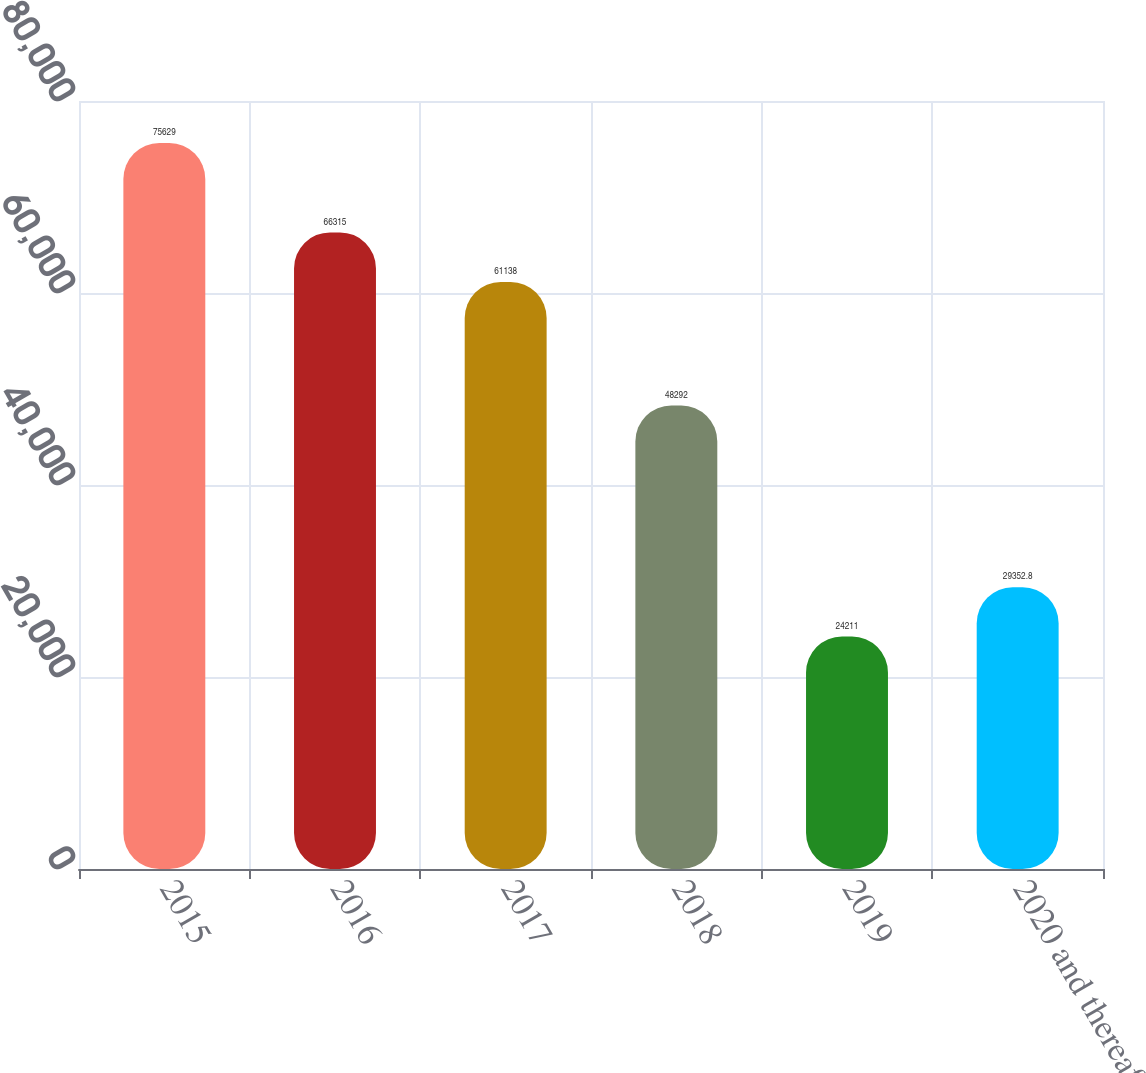Convert chart to OTSL. <chart><loc_0><loc_0><loc_500><loc_500><bar_chart><fcel>2015<fcel>2016<fcel>2017<fcel>2018<fcel>2019<fcel>2020 and thereafter<nl><fcel>75629<fcel>66315<fcel>61138<fcel>48292<fcel>24211<fcel>29352.8<nl></chart> 